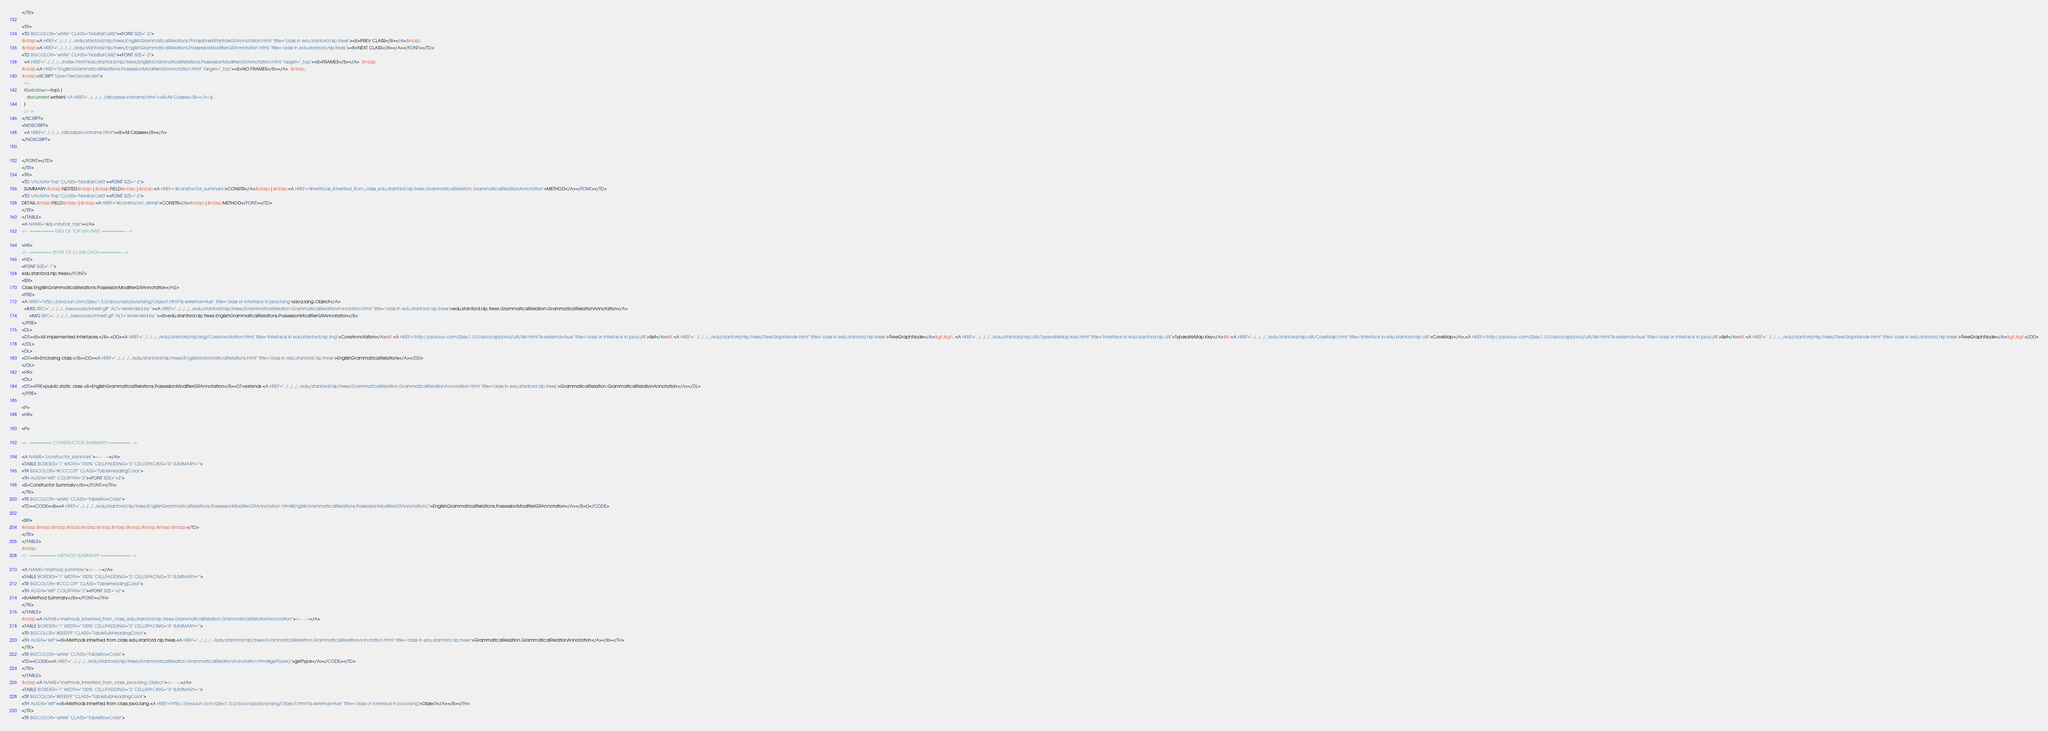<code> <loc_0><loc_0><loc_500><loc_500><_HTML_></TR>

<TR>
<TD BGCOLOR="white" CLASS="NavBarCell2"><FONT SIZE="-2">
&nbsp;<A HREF="../../../../edu/stanford/nlp/trees/EnglishGrammaticalRelations.PhrasalVerbParticleGRAnnotation.html" title="class in edu.stanford.nlp.trees"><B>PREV CLASS</B></A>&nbsp;
&nbsp;<A HREF="../../../../edu/stanford/nlp/trees/EnglishGrammaticalRelations.PossessiveModifierGRAnnotation.html" title="class in edu.stanford.nlp.trees"><B>NEXT CLASS</B></A></FONT></TD>
<TD BGCOLOR="white" CLASS="NavBarCell2"><FONT SIZE="-2">
  <A HREF="../../../../index.html?edu/stanford/nlp/trees/EnglishGrammaticalRelations.PossessionModifierGRAnnotation.html" target="_top"><B>FRAMES</B></A>  &nbsp;
&nbsp;<A HREF="EnglishGrammaticalRelations.PossessionModifierGRAnnotation.html" target="_top"><B>NO FRAMES</B></A>  &nbsp;
&nbsp;<SCRIPT type="text/javascript">
  <!--
  if(window==top) {
    document.writeln('<A HREF="../../../../allclasses-noframe.html"><B>All Classes</B></A>');
  }
  //-->
</SCRIPT>
<NOSCRIPT>
  <A HREF="../../../../allclasses-noframe.html"><B>All Classes</B></A>
</NOSCRIPT>


</FONT></TD>
</TR>
<TR>
<TD VALIGN="top" CLASS="NavBarCell3"><FONT SIZE="-2">
  SUMMARY:&nbsp;NESTED&nbsp;|&nbsp;FIELD&nbsp;|&nbsp;<A HREF="#constructor_summary">CONSTR</A>&nbsp;|&nbsp;<A HREF="#methods_inherited_from_class_edu.stanford.nlp.trees.GrammaticalRelation.GrammaticalRelationAnnotation">METHOD</A></FONT></TD>
<TD VALIGN="top" CLASS="NavBarCell3"><FONT SIZE="-2">
DETAIL:&nbsp;FIELD&nbsp;|&nbsp;<A HREF="#constructor_detail">CONSTR</A>&nbsp;|&nbsp;METHOD</FONT></TD>
</TR>
</TABLE>
<A NAME="skip-navbar_top"></A>
<!-- ========= END OF TOP NAVBAR ========= -->

<HR>
<!-- ======== START OF CLASS DATA ======== -->
<H2>
<FONT SIZE="-1">
edu.stanford.nlp.trees</FONT>
<BR>
Class EnglishGrammaticalRelations.PossessionModifierGRAnnotation</H2>
<PRE>
<A HREF="http://java.sun.com/j2se/1.5.0/docs/api/java/lang/Object.html?is-external=true" title="class or interface in java.lang">java.lang.Object</A>
  <IMG SRC="../../../../resources/inherit.gif" ALT="extended by "><A HREF="../../../../edu/stanford/nlp/trees/GrammaticalRelation.GrammaticalRelationAnnotation.html" title="class in edu.stanford.nlp.trees">edu.stanford.nlp.trees.GrammaticalRelation.GrammaticalRelationAnnotation</A>
      <IMG SRC="../../../../resources/inherit.gif" ALT="extended by "><B>edu.stanford.nlp.trees.EnglishGrammaticalRelations.PossessionModifierGRAnnotation</B>
</PRE>
<DL>
<DT><B>All Implemented Interfaces:</B> <DD><A HREF="../../../../edu/stanford/nlp/ling/CoreAnnotation.html" title="interface in edu.stanford.nlp.ling">CoreAnnotation</A>&lt;<A HREF="http://java.sun.com/j2se/1.5.0/docs/api/java/util/Set.html?is-external=true" title="class or interface in java.util">Set</A>&lt;<A HREF="../../../../edu/stanford/nlp/trees/TreeGraphNode.html" title="class in edu.stanford.nlp.trees">TreeGraphNode</A>&gt;&gt;, <A HREF="../../../../edu/stanford/nlp/util/TypesafeMap.Key.html" title="interface in edu.stanford.nlp.util">TypesafeMap.Key</A>&lt;<A HREF="../../../../edu/stanford/nlp/util/CoreMap.html" title="interface in edu.stanford.nlp.util">CoreMap</A>,<A HREF="http://java.sun.com/j2se/1.5.0/docs/api/java/util/Set.html?is-external=true" title="class or interface in java.util">Set</A>&lt;<A HREF="../../../../edu/stanford/nlp/trees/TreeGraphNode.html" title="class in edu.stanford.nlp.trees">TreeGraphNode</A>&gt;&gt;</DD>
</DL>
<DL>
<DT><B>Enclosing class:</B><DD><A HREF="../../../../edu/stanford/nlp/trees/EnglishGrammaticalRelations.html" title="class in edu.stanford.nlp.trees">EnglishGrammaticalRelations</A></DD>
</DL>
<HR>
<DL>
<DT><PRE>public static class <B>EnglishGrammaticalRelations.PossessionModifierGRAnnotation</B><DT>extends <A HREF="../../../../edu/stanford/nlp/trees/GrammaticalRelation.GrammaticalRelationAnnotation.html" title="class in edu.stanford.nlp.trees">GrammaticalRelation.GrammaticalRelationAnnotation</A></DL>
</PRE>

<P>
<HR>

<P>

<!-- ======== CONSTRUCTOR SUMMARY ======== -->

<A NAME="constructor_summary"><!-- --></A>
<TABLE BORDER="1" WIDTH="100%" CELLPADDING="3" CELLSPACING="0" SUMMARY="">
<TR BGCOLOR="#CCCCFF" CLASS="TableHeadingColor">
<TH ALIGN="left" COLSPAN="2"><FONT SIZE="+2">
<B>Constructor Summary</B></FONT></TH>
</TR>
<TR BGCOLOR="white" CLASS="TableRowColor">
<TD><CODE><B><A HREF="../../../../edu/stanford/nlp/trees/EnglishGrammaticalRelations.PossessionModifierGRAnnotation.html#EnglishGrammaticalRelations.PossessionModifierGRAnnotation()">EnglishGrammaticalRelations.PossessionModifierGRAnnotation</A></B>()</CODE>

<BR>
&nbsp;&nbsp;&nbsp;&nbsp;&nbsp;&nbsp;&nbsp;&nbsp;&nbsp;&nbsp;&nbsp;</TD>
</TR>
</TABLE>
&nbsp;
<!-- ========== METHOD SUMMARY =========== -->

<A NAME="method_summary"><!-- --></A>
<TABLE BORDER="1" WIDTH="100%" CELLPADDING="3" CELLSPACING="0" SUMMARY="">
<TR BGCOLOR="#CCCCFF" CLASS="TableHeadingColor">
<TH ALIGN="left" COLSPAN="2"><FONT SIZE="+2">
<B>Method Summary</B></FONT></TH>
</TR>
</TABLE>
&nbsp;<A NAME="methods_inherited_from_class_edu.stanford.nlp.trees.GrammaticalRelation.GrammaticalRelationAnnotation"><!-- --></A>
<TABLE BORDER="1" WIDTH="100%" CELLPADDING="3" CELLSPACING="0" SUMMARY="">
<TR BGCOLOR="#EEEEFF" CLASS="TableSubHeadingColor">
<TH ALIGN="left"><B>Methods inherited from class edu.stanford.nlp.trees.<A HREF="../../../../edu/stanford/nlp/trees/GrammaticalRelation.GrammaticalRelationAnnotation.html" title="class in edu.stanford.nlp.trees">GrammaticalRelation.GrammaticalRelationAnnotation</A></B></TH>
</TR>
<TR BGCOLOR="white" CLASS="TableRowColor">
<TD><CODE><A HREF="../../../../edu/stanford/nlp/trees/GrammaticalRelation.GrammaticalRelationAnnotation.html#getType()">getType</A></CODE></TD>
</TR>
</TABLE>
&nbsp;<A NAME="methods_inherited_from_class_java.lang.Object"><!-- --></A>
<TABLE BORDER="1" WIDTH="100%" CELLPADDING="3" CELLSPACING="0" SUMMARY="">
<TR BGCOLOR="#EEEEFF" CLASS="TableSubHeadingColor">
<TH ALIGN="left"><B>Methods inherited from class java.lang.<A HREF="http://java.sun.com/j2se/1.5.0/docs/api/java/lang/Object.html?is-external=true" title="class or interface in java.lang">Object</A></B></TH>
</TR>
<TR BGCOLOR="white" CLASS="TableRowColor"></code> 